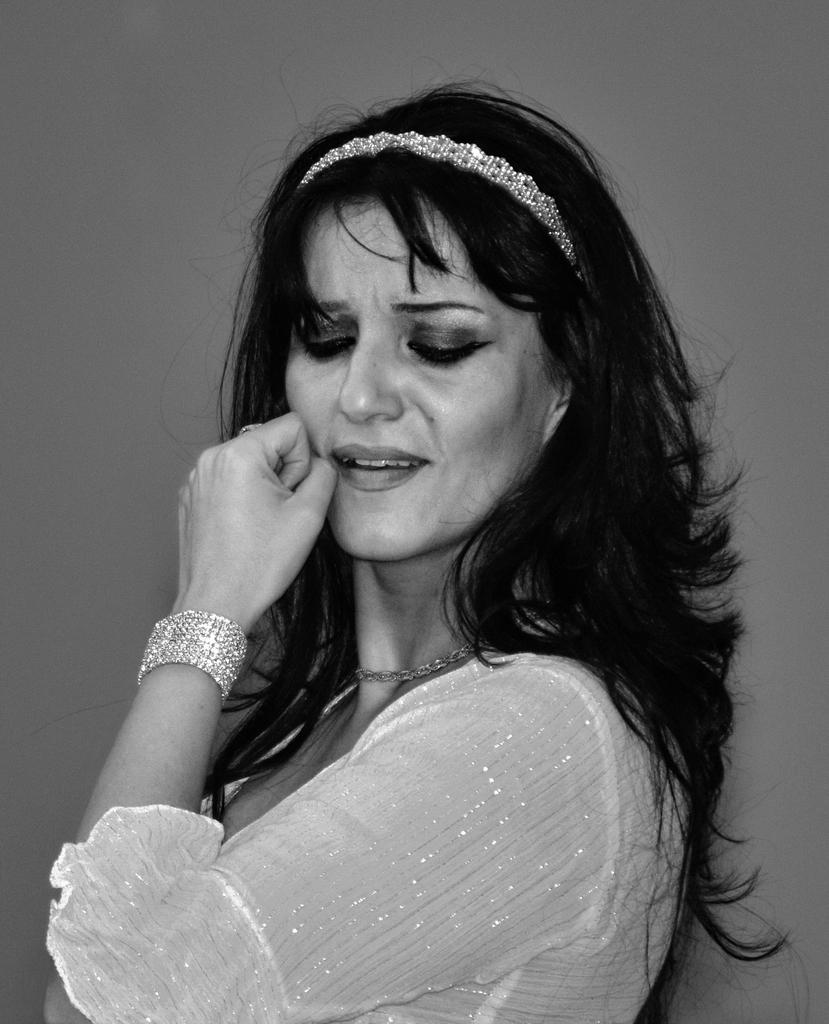What is present in the image? There is a person in the image. Can you describe the person's attire? The person is wearing clothes. How much salt is on the person's chin in the image? There is no salt or chin visible in the image; it only shows a person wearing clothes. 